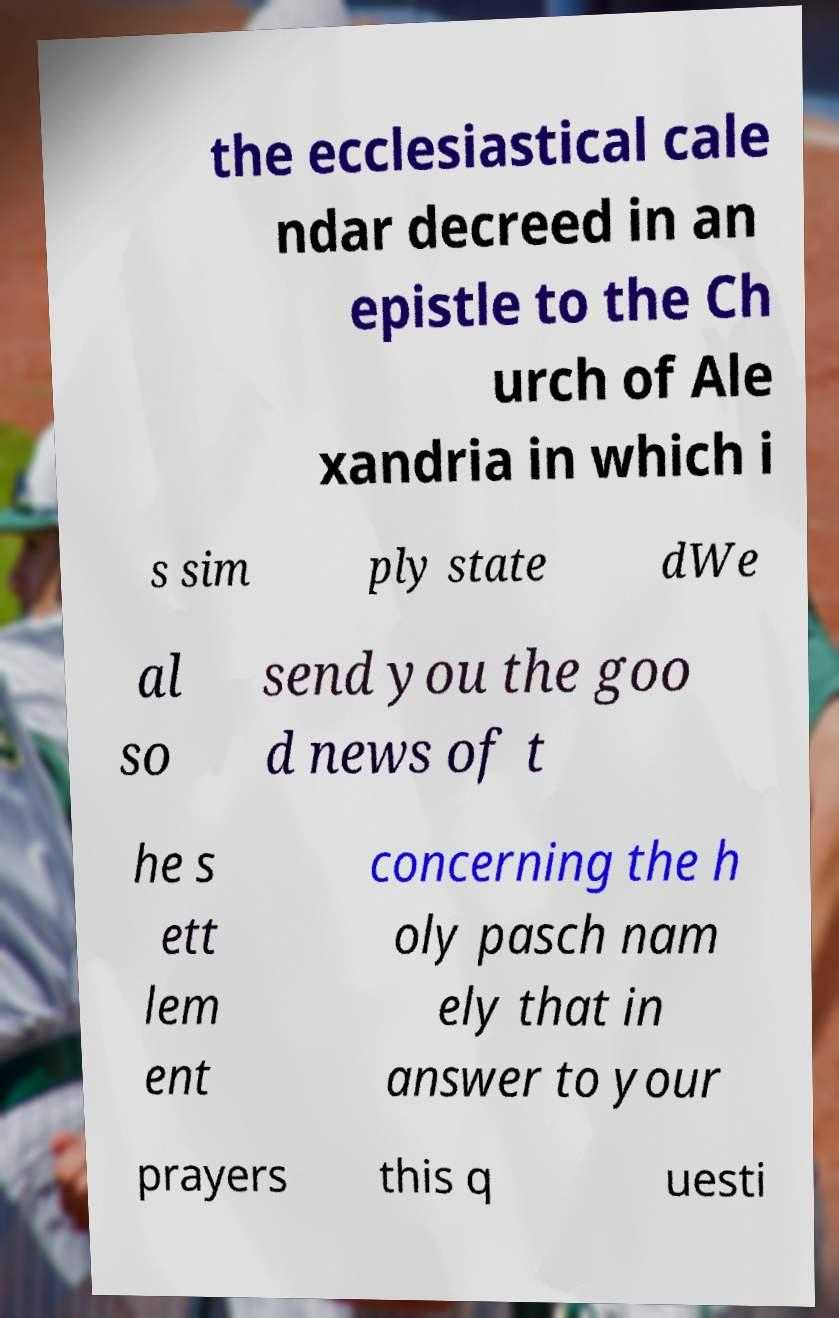There's text embedded in this image that I need extracted. Can you transcribe it verbatim? the ecclesiastical cale ndar decreed in an epistle to the Ch urch of Ale xandria in which i s sim ply state dWe al so send you the goo d news of t he s ett lem ent concerning the h oly pasch nam ely that in answer to your prayers this q uesti 